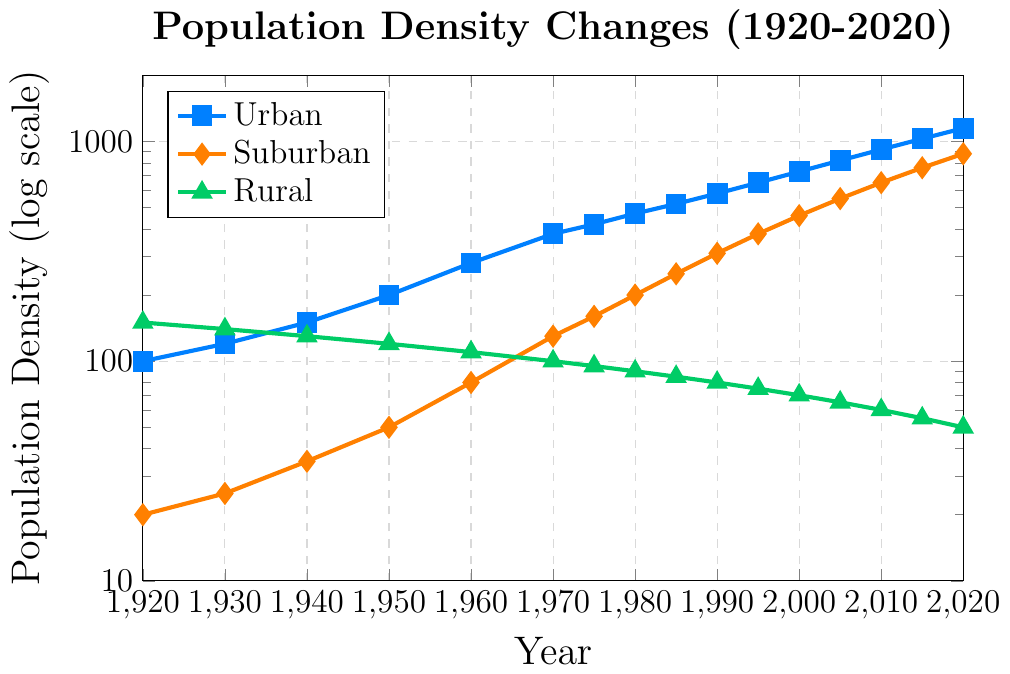What is the population density of urban areas in 1960? To find the population density of urban areas in 1960, locate the 'Urban' series (marked with square markers) and find the point corresponding to the year 1960 on the x-axis. Read the y-axis value at this point.
Answer: 280 How has the population density of rural areas changed from 1920 to 2020? To determine the change, locate the first and last values for the 'Rural' series (marked with triangle markers). The population density in 1920 is 150, and in 2020 it is 50. Calculate the difference: 150 - 50.
Answer: Decreased by 100 Which year had the highest population density for suburban areas? To find the year with the highest density for suburban areas, locate the 'Suburban' series (marked with diamond markers) and identify the highest point. The highest value appears at the end of the series, corresponding to the year 2020.
Answer: 2020 Compare the population density of urban and suburban areas in 1990. To compare these two, find the points for urban and suburban areas in 1990 on their respective series. The urban density is at 580, while the suburban density is at 310. Thus, urban density is higher.
Answer: Urban is higher By how much did the population density in urban areas increase between 2000 and 2020? To find the increase, locate the population densities for urban areas in 2000 and 2020. The values are 730 and 1150, respectively. Calculate the difference: 1150 - 730.
Answer: Increased by 420 What is the total population density of urban, suburban, and rural areas in 1970? Locate the population densities for urban (380), suburban (130), and rural (100) areas in 1970, then sum these values: 380 + 130 + 100.
Answer: 610 Which area, suburban or rural, had a higher population density in 1950? Compare the values for suburban (50) and rural (120) areas in 1950. The rural area has a higher population density.
Answer: Rural What is the visual difference in the color of the lines representing urban and rural areas? The lines representing urban and rural areas are different colors. Urban is blue, while rural is green.
Answer: Urban is blue, rural is green How did the population density of suburban areas change from 1980 to 2000? Find the population densities for suburban areas in 1980 (200) and 2000 (460), then calculate the increase: 460 - 200.
Answer: Increased by 260 